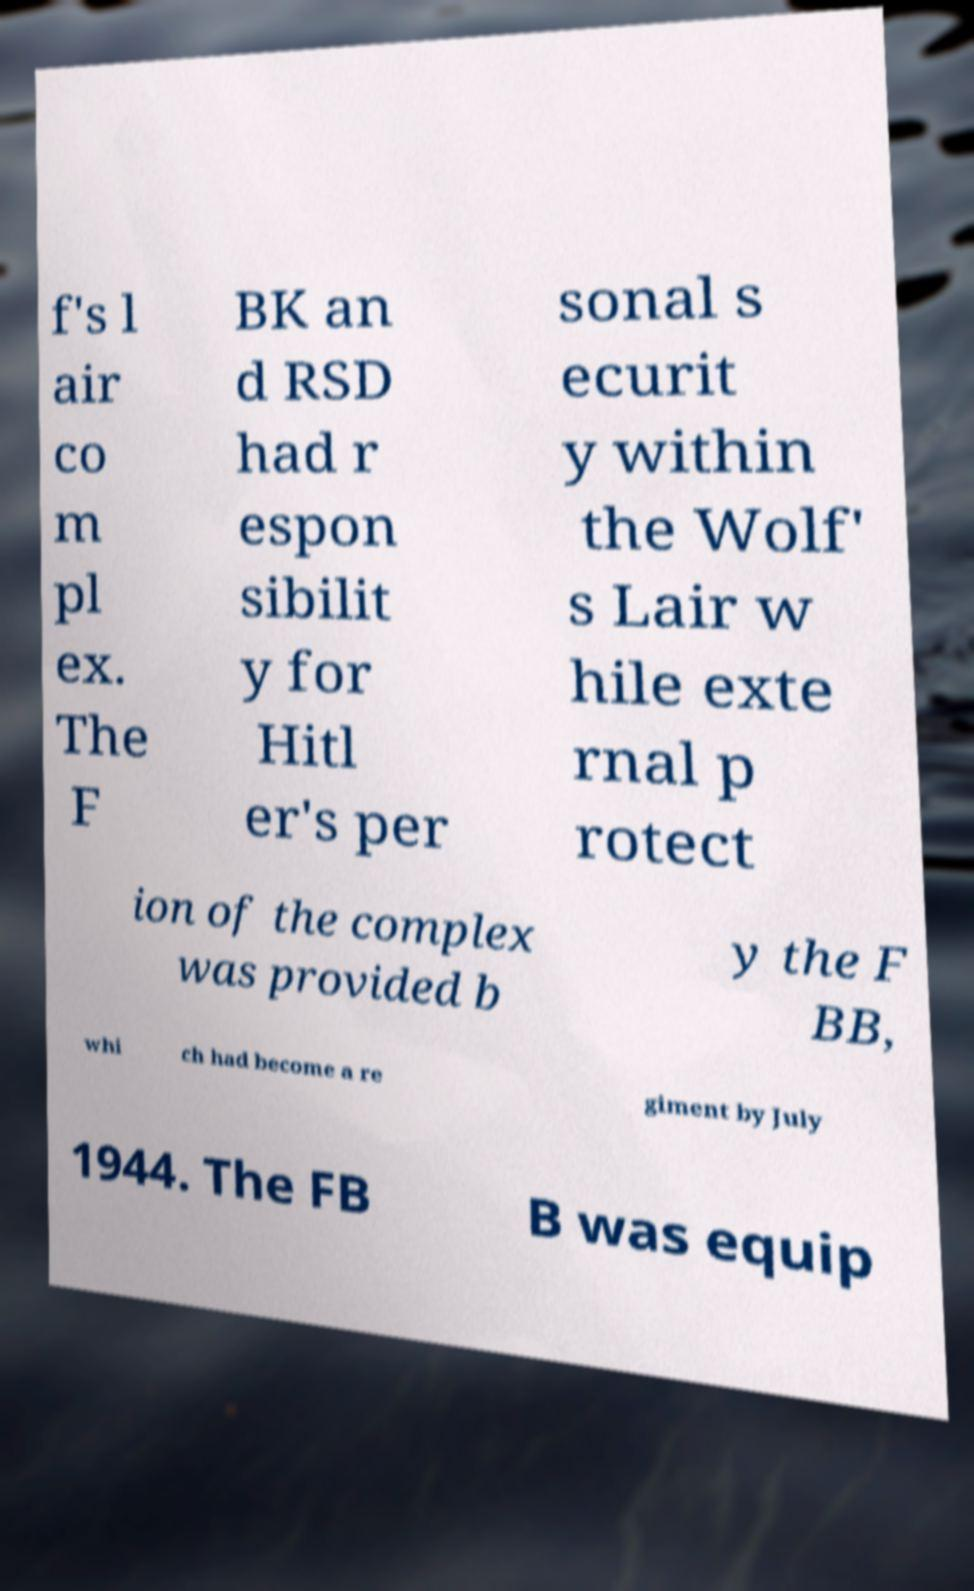Could you extract and type out the text from this image? f's l air co m pl ex. The F BK an d RSD had r espon sibilit y for Hitl er's per sonal s ecurit y within the Wolf' s Lair w hile exte rnal p rotect ion of the complex was provided b y the F BB, whi ch had become a re giment by July 1944. The FB B was equip 